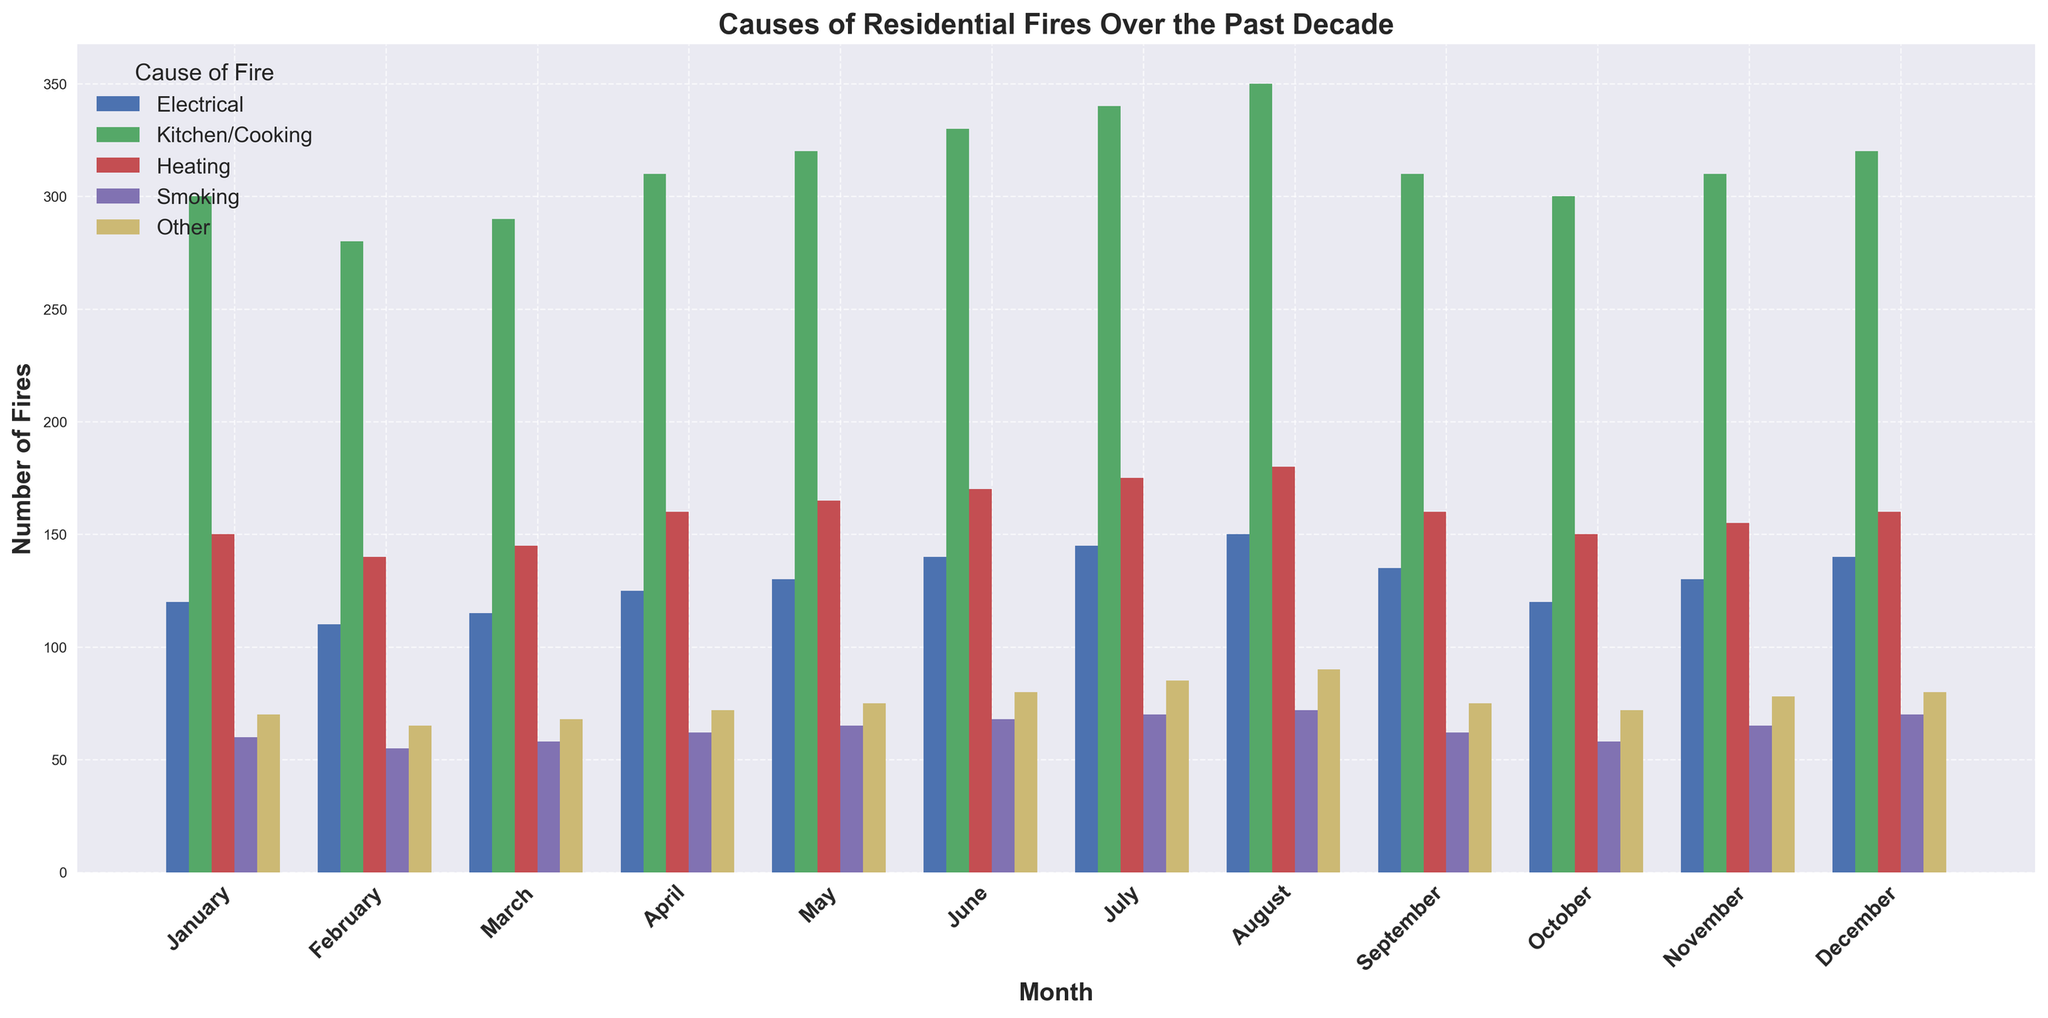Which month had the highest number of kitchen/cooking-related fires? To find the month with the highest number of kitchen/cooking-related fires, visually inspect the height of the bars labeled "Kitchen/Cooking" for each month and identify the tallest. This corresponds to the month of August.
Answer: August What is the total number of electrical fires in the first quarter of the year? The first quarter includes January, February, and March. Sum the number of electrical fires for these months: 120 (January) + 110 (February) + 115 (March) = 345.
Answer: 345 In which month were smoking-related fires the lowest? To determine the month with the lowest smoking-related fires, look for the shortest bar in the "Smoking" category. The lowest bar corresponds to February.
Answer: February How does the number of heating fires in December compare to July? Compare the height of the bars for "Heating" in December (160) and July (175). December's number is lower than July's number.
Answer: December has fewer heating fires What is the average number of fires caused by smoking in the months of June, July, and August? Calculate the average by summing the smoking-related fires in June (68), July (70), and August (72) and then dividing by 3: (68 + 70 + 72) / 3 = 70.
Answer: 70 Which category of fires has the highest frequency in October? Inspect the heights of all the bars in October and identify the tallest one. "Kitchen/Cooking" has the highest frequency with 300 fires.
Answer: Kitchen/Cooking Are there any months in which the number of fires caused by "Other" matches the number of fires caused by "Heating"? Compare the bar heights of the "Other" and "Heating" categories for each month. In September, both categories have 160 fires.
Answer: Yes, in September How do the total number of fires in March compare to April? Sum the fires for each category in March (115+290+145+58+68=676) and April (125+310+160+62+72=729). March has fewer total fires.
Answer: March has fewer fires What is the difference in the number of fires caused by electrical issues between January and December? Subtract the number of electrical fires in January (120) from December (140): 140 - 120 = 20.
Answer: 20 